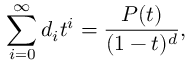<formula> <loc_0><loc_0><loc_500><loc_500>\sum _ { i = 0 } ^ { \infty } d _ { i } t ^ { i } = { \frac { P ( t ) } { ( 1 - t ) ^ { d } } } ,</formula> 